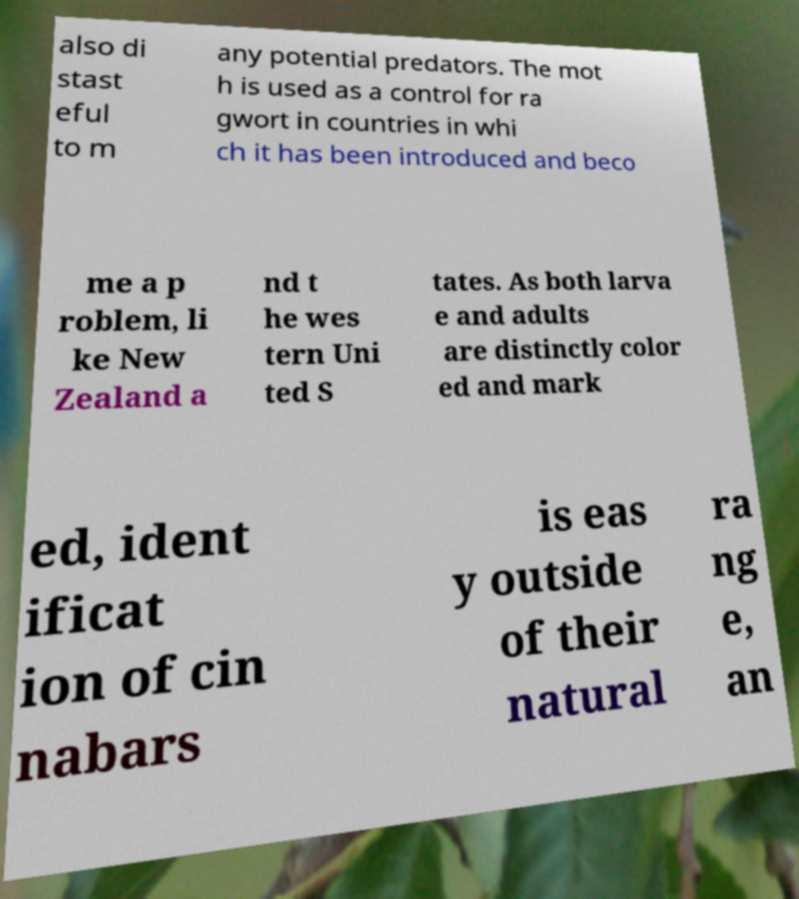Please identify and transcribe the text found in this image. also di stast eful to m any potential predators. The mot h is used as a control for ra gwort in countries in whi ch it has been introduced and beco me a p roblem, li ke New Zealand a nd t he wes tern Uni ted S tates. As both larva e and adults are distinctly color ed and mark ed, ident ificat ion of cin nabars is eas y outside of their natural ra ng e, an 